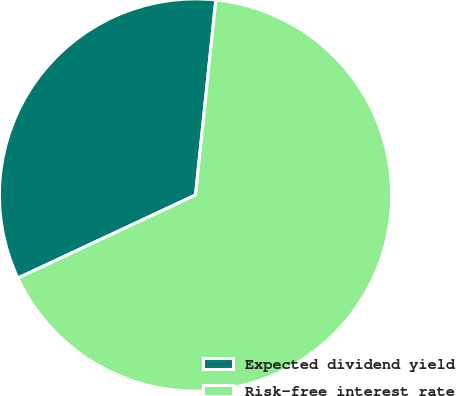Convert chart. <chart><loc_0><loc_0><loc_500><loc_500><pie_chart><fcel>Expected dividend yield<fcel>Risk-free interest rate<nl><fcel>33.61%<fcel>66.39%<nl></chart> 